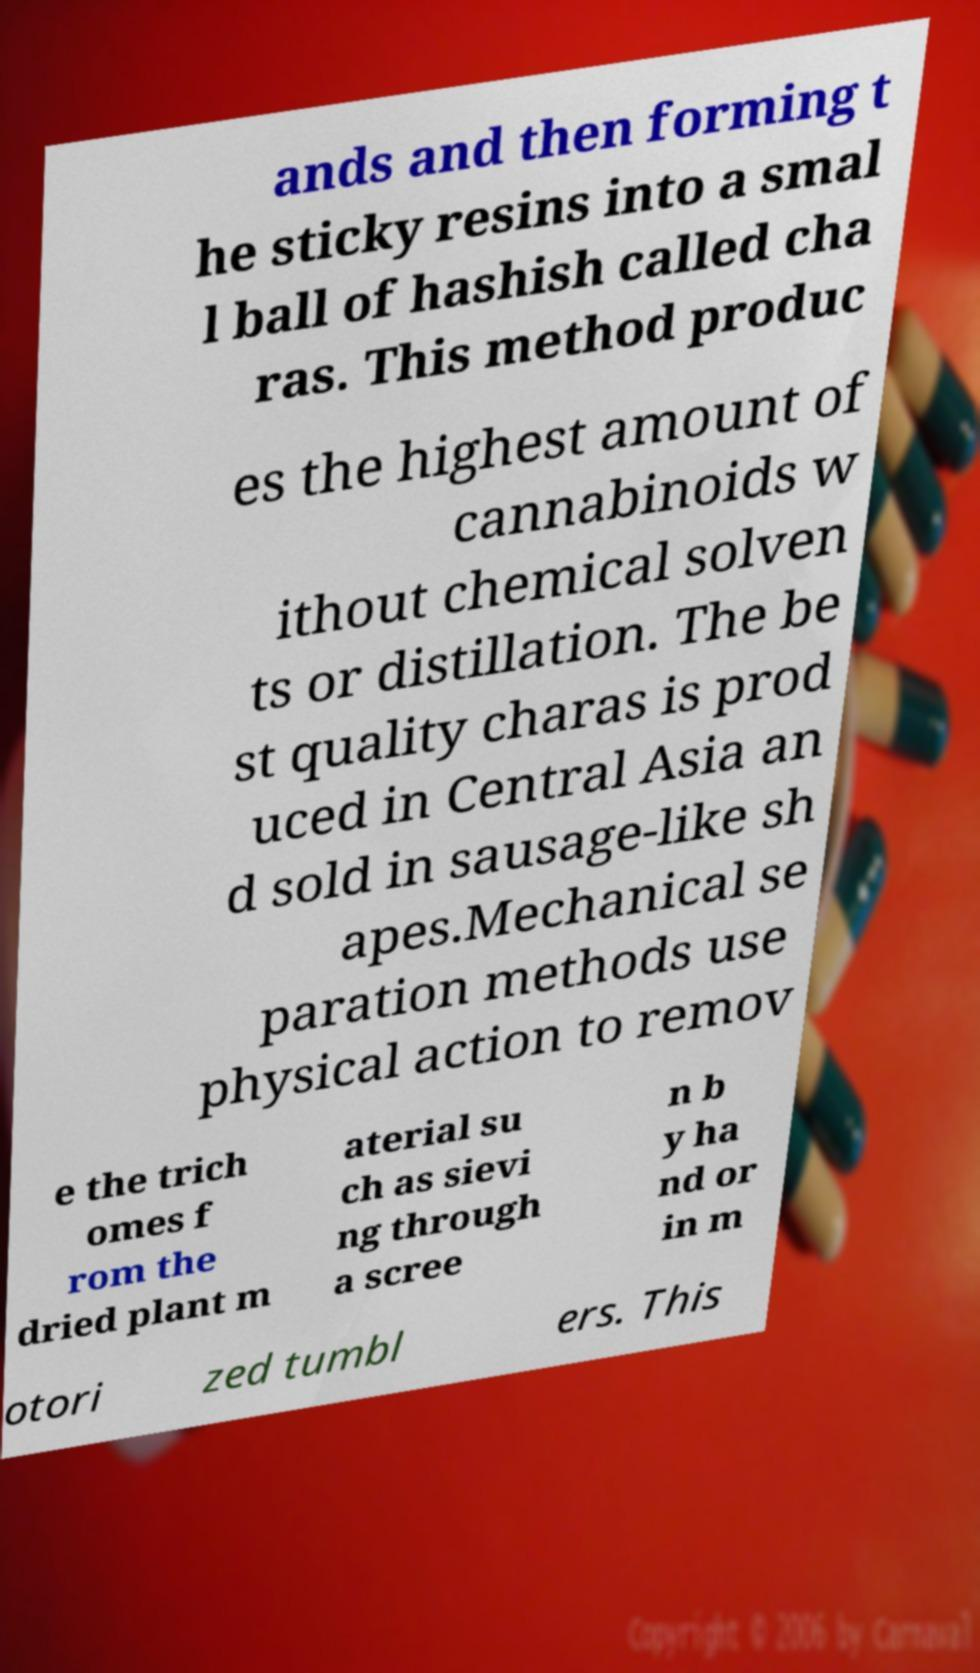Please read and relay the text visible in this image. What does it say? ands and then forming t he sticky resins into a smal l ball of hashish called cha ras. This method produc es the highest amount of cannabinoids w ithout chemical solven ts or distillation. The be st quality charas is prod uced in Central Asia an d sold in sausage-like sh apes.Mechanical se paration methods use physical action to remov e the trich omes f rom the dried plant m aterial su ch as sievi ng through a scree n b y ha nd or in m otori zed tumbl ers. This 